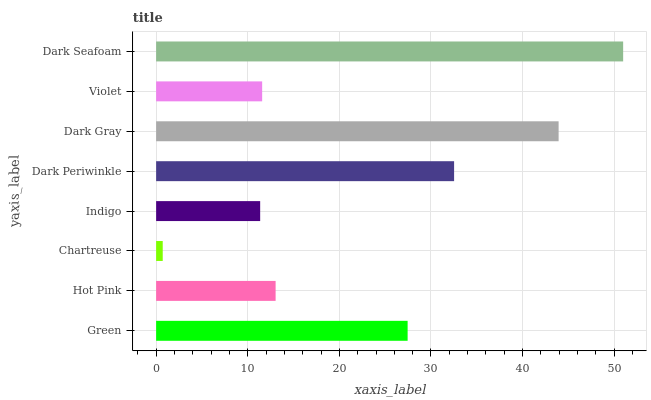Is Chartreuse the minimum?
Answer yes or no. Yes. Is Dark Seafoam the maximum?
Answer yes or no. Yes. Is Hot Pink the minimum?
Answer yes or no. No. Is Hot Pink the maximum?
Answer yes or no. No. Is Green greater than Hot Pink?
Answer yes or no. Yes. Is Hot Pink less than Green?
Answer yes or no. Yes. Is Hot Pink greater than Green?
Answer yes or no. No. Is Green less than Hot Pink?
Answer yes or no. No. Is Green the high median?
Answer yes or no. Yes. Is Hot Pink the low median?
Answer yes or no. Yes. Is Dark Gray the high median?
Answer yes or no. No. Is Chartreuse the low median?
Answer yes or no. No. 